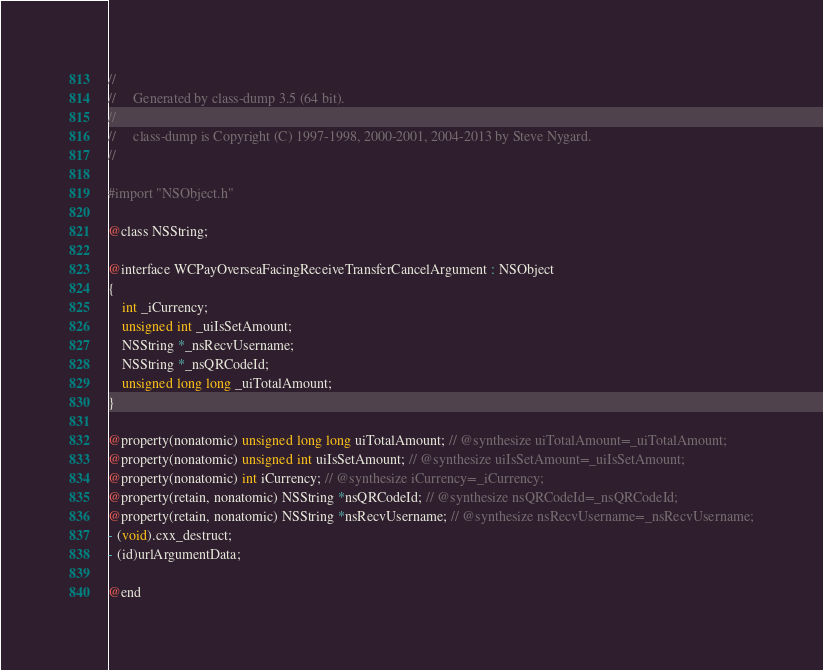<code> <loc_0><loc_0><loc_500><loc_500><_C_>//
//     Generated by class-dump 3.5 (64 bit).
//
//     class-dump is Copyright (C) 1997-1998, 2000-2001, 2004-2013 by Steve Nygard.
//

#import "NSObject.h"

@class NSString;

@interface WCPayOverseaFacingReceiveTransferCancelArgument : NSObject
{
    int _iCurrency;
    unsigned int _uiIsSetAmount;
    NSString *_nsRecvUsername;
    NSString *_nsQRCodeId;
    unsigned long long _uiTotalAmount;
}

@property(nonatomic) unsigned long long uiTotalAmount; // @synthesize uiTotalAmount=_uiTotalAmount;
@property(nonatomic) unsigned int uiIsSetAmount; // @synthesize uiIsSetAmount=_uiIsSetAmount;
@property(nonatomic) int iCurrency; // @synthesize iCurrency=_iCurrency;
@property(retain, nonatomic) NSString *nsQRCodeId; // @synthesize nsQRCodeId=_nsQRCodeId;
@property(retain, nonatomic) NSString *nsRecvUsername; // @synthesize nsRecvUsername=_nsRecvUsername;
- (void).cxx_destruct;
- (id)urlArgumentData;

@end

</code> 